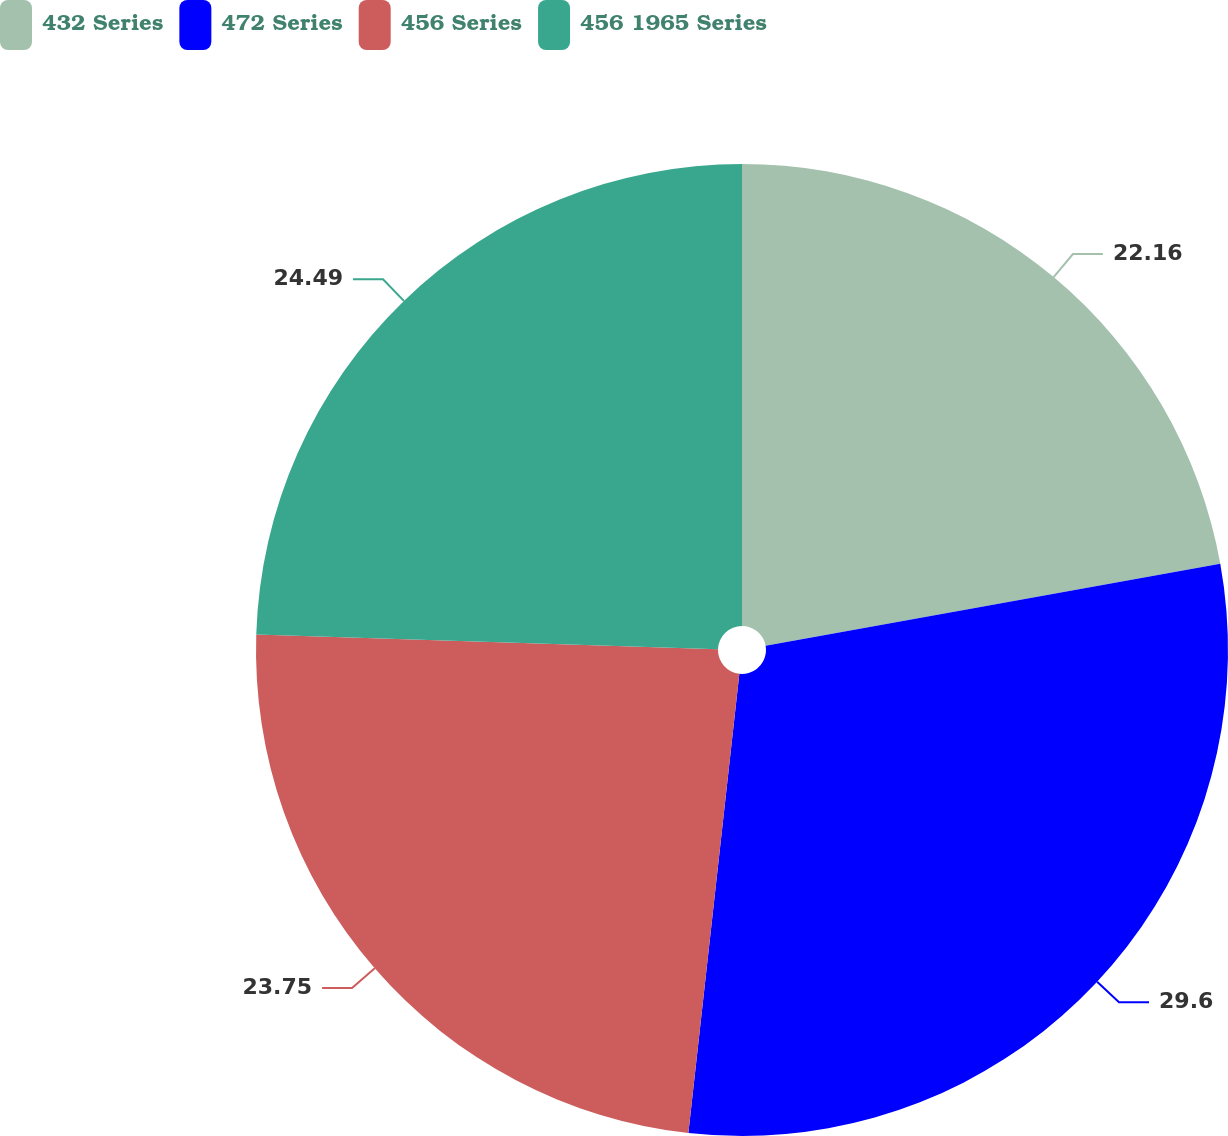Convert chart to OTSL. <chart><loc_0><loc_0><loc_500><loc_500><pie_chart><fcel>432 Series<fcel>472 Series<fcel>456 Series<fcel>456 1965 Series<nl><fcel>22.16%<fcel>29.6%<fcel>23.75%<fcel>24.49%<nl></chart> 